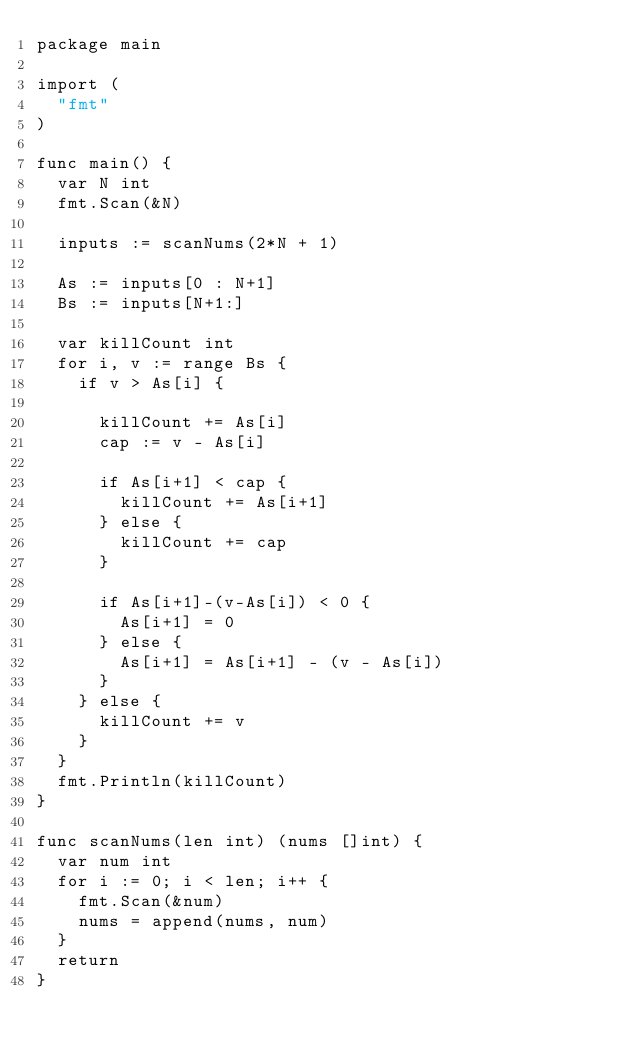<code> <loc_0><loc_0><loc_500><loc_500><_Go_>package main

import (
	"fmt"
)

func main() {
	var N int
	fmt.Scan(&N)

	inputs := scanNums(2*N + 1)

	As := inputs[0 : N+1]
	Bs := inputs[N+1:]

	var killCount int
	for i, v := range Bs {
		if v > As[i] {

			killCount += As[i]
			cap := v - As[i]

			if As[i+1] < cap {
				killCount += As[i+1]
			} else {
				killCount += cap
			}

			if As[i+1]-(v-As[i]) < 0 {
				As[i+1] = 0
			} else {
				As[i+1] = As[i+1] - (v - As[i])
			}
		} else {
			killCount += v
		}
	}
	fmt.Println(killCount)
}

func scanNums(len int) (nums []int) {
	var num int
	for i := 0; i < len; i++ {
		fmt.Scan(&num)
		nums = append(nums, num)
	}
	return
}
</code> 